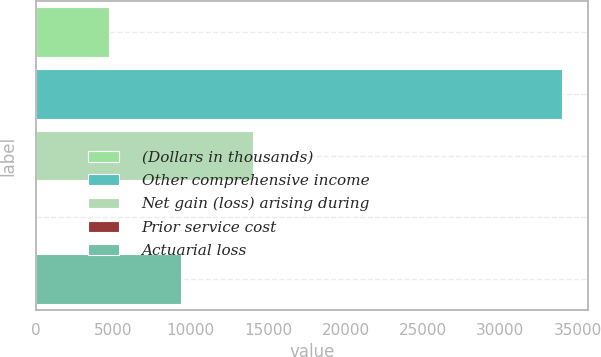Convert chart to OTSL. <chart><loc_0><loc_0><loc_500><loc_500><bar_chart><fcel>(Dollars in thousands)<fcel>Other comprehensive income<fcel>Net gain (loss) arising during<fcel>Prior service cost<fcel>Actuarial loss<nl><fcel>4700.8<fcel>33974<fcel>14004.4<fcel>49<fcel>9352.6<nl></chart> 